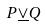Convert formula to latex. <formula><loc_0><loc_0><loc_500><loc_500>P \underline { \vee } Q</formula> 